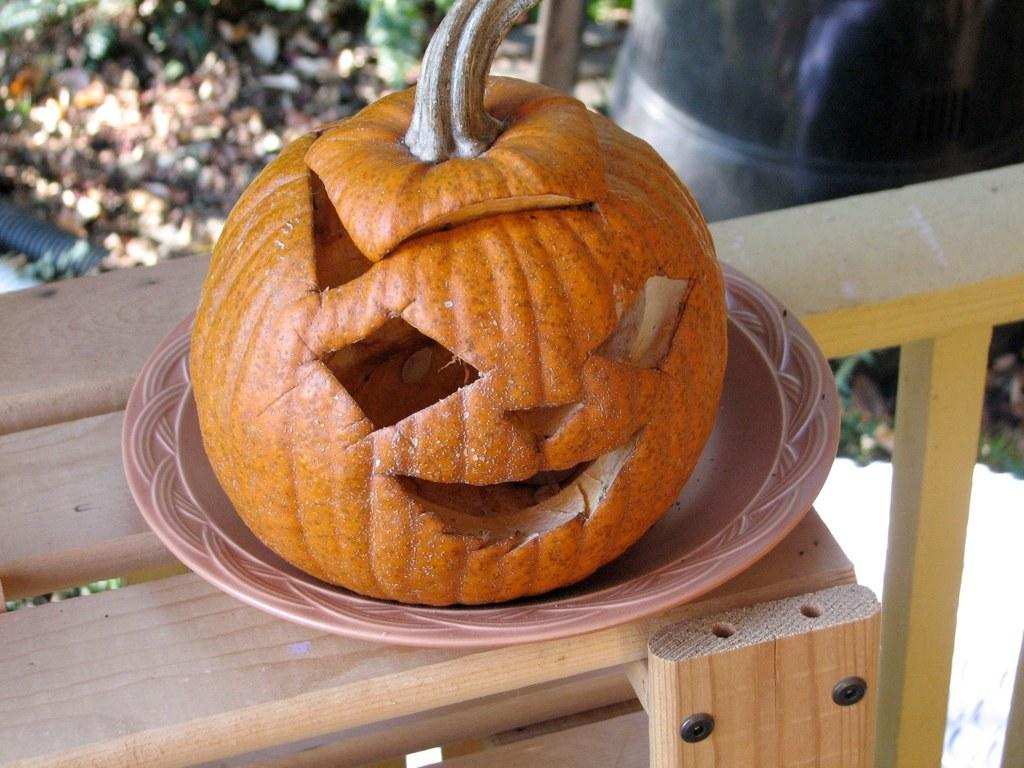What is the main subject of the image? There is a pumpkin in a plate in the image. What is the plate resting on? The plate is on a wooden object. What can be seen in the background of the image? There are leaves and objects on the ground in the background of the image. What type of list can be seen hanging on the pumpkin in the image? There is no list present in the image; it features a pumpkin in a plate on a wooden object, with leaves and objects on the ground in the background. 